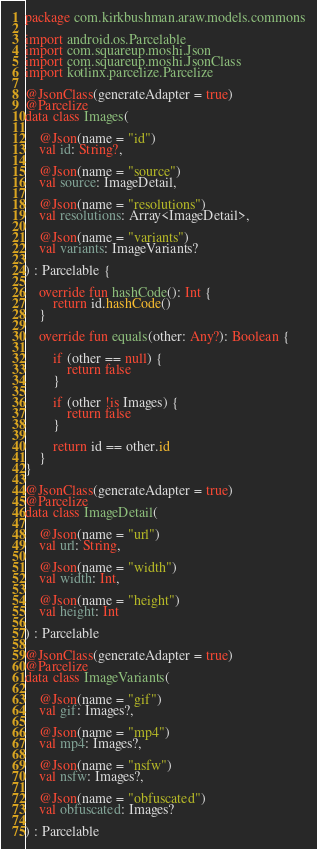Convert code to text. <code><loc_0><loc_0><loc_500><loc_500><_Kotlin_>package com.kirkbushman.araw.models.commons

import android.os.Parcelable
import com.squareup.moshi.Json
import com.squareup.moshi.JsonClass
import kotlinx.parcelize.Parcelize

@JsonClass(generateAdapter = true)
@Parcelize
data class Images(

    @Json(name = "id")
    val id: String?,

    @Json(name = "source")
    val source: ImageDetail,

    @Json(name = "resolutions")
    val resolutions: Array<ImageDetail>,

    @Json(name = "variants")
    val variants: ImageVariants?

) : Parcelable {

    override fun hashCode(): Int {
        return id.hashCode()
    }

    override fun equals(other: Any?): Boolean {

        if (other == null) {
            return false
        }

        if (other !is Images) {
            return false
        }

        return id == other.id
    }
}

@JsonClass(generateAdapter = true)
@Parcelize
data class ImageDetail(

    @Json(name = "url")
    val url: String,

    @Json(name = "width")
    val width: Int,

    @Json(name = "height")
    val height: Int

) : Parcelable

@JsonClass(generateAdapter = true)
@Parcelize
data class ImageVariants(

    @Json(name = "gif")
    val gif: Images?,

    @Json(name = "mp4")
    val mp4: Images?,

    @Json(name = "nsfw")
    val nsfw: Images?,

    @Json(name = "obfuscated")
    val obfuscated: Images?

) : Parcelable
</code> 